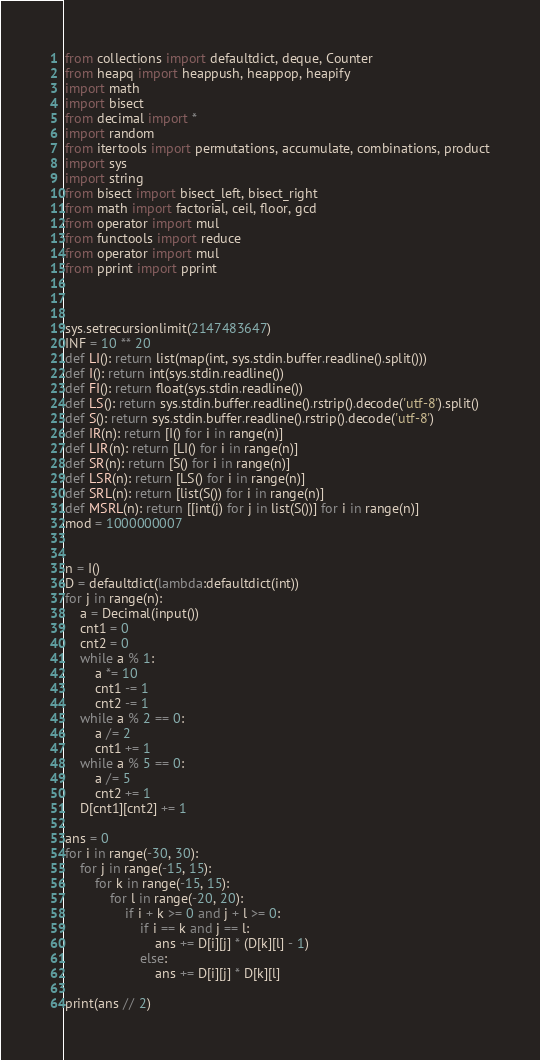<code> <loc_0><loc_0><loc_500><loc_500><_Python_>from collections import defaultdict, deque, Counter
from heapq import heappush, heappop, heapify
import math
import bisect
from decimal import *
import random
from itertools import permutations, accumulate, combinations, product
import sys
import string
from bisect import bisect_left, bisect_right
from math import factorial, ceil, floor, gcd
from operator import mul
from functools import reduce
from operator import mul
from pprint import pprint



sys.setrecursionlimit(2147483647)
INF = 10 ** 20
def LI(): return list(map(int, sys.stdin.buffer.readline().split()))
def I(): return int(sys.stdin.readline())
def FI(): return float(sys.stdin.readline())
def LS(): return sys.stdin.buffer.readline().rstrip().decode('utf-8').split()
def S(): return sys.stdin.buffer.readline().rstrip().decode('utf-8')
def IR(n): return [I() for i in range(n)]
def LIR(n): return [LI() for i in range(n)]
def SR(n): return [S() for i in range(n)]
def LSR(n): return [LS() for i in range(n)]
def SRL(n): return [list(S()) for i in range(n)]
def MSRL(n): return [[int(j) for j in list(S())] for i in range(n)]
mod = 1000000007


n = I()
D = defaultdict(lambda:defaultdict(int))
for j in range(n):
    a = Decimal(input())
    cnt1 = 0
    cnt2 = 0
    while a % 1:
        a *= 10
        cnt1 -= 1
        cnt2 -= 1
    while a % 2 == 0:
        a /= 2
        cnt1 += 1
    while a % 5 == 0:
        a /= 5
        cnt2 += 1
    D[cnt1][cnt2] += 1

ans = 0
for i in range(-30, 30):
    for j in range(-15, 15):
        for k in range(-15, 15):
            for l in range(-20, 20):
                if i + k >= 0 and j + l >= 0:
                    if i == k and j == l:
                        ans += D[i][j] * (D[k][l] - 1)
                    else:
                        ans += D[i][j] * D[k][l]

print(ans // 2)
</code> 